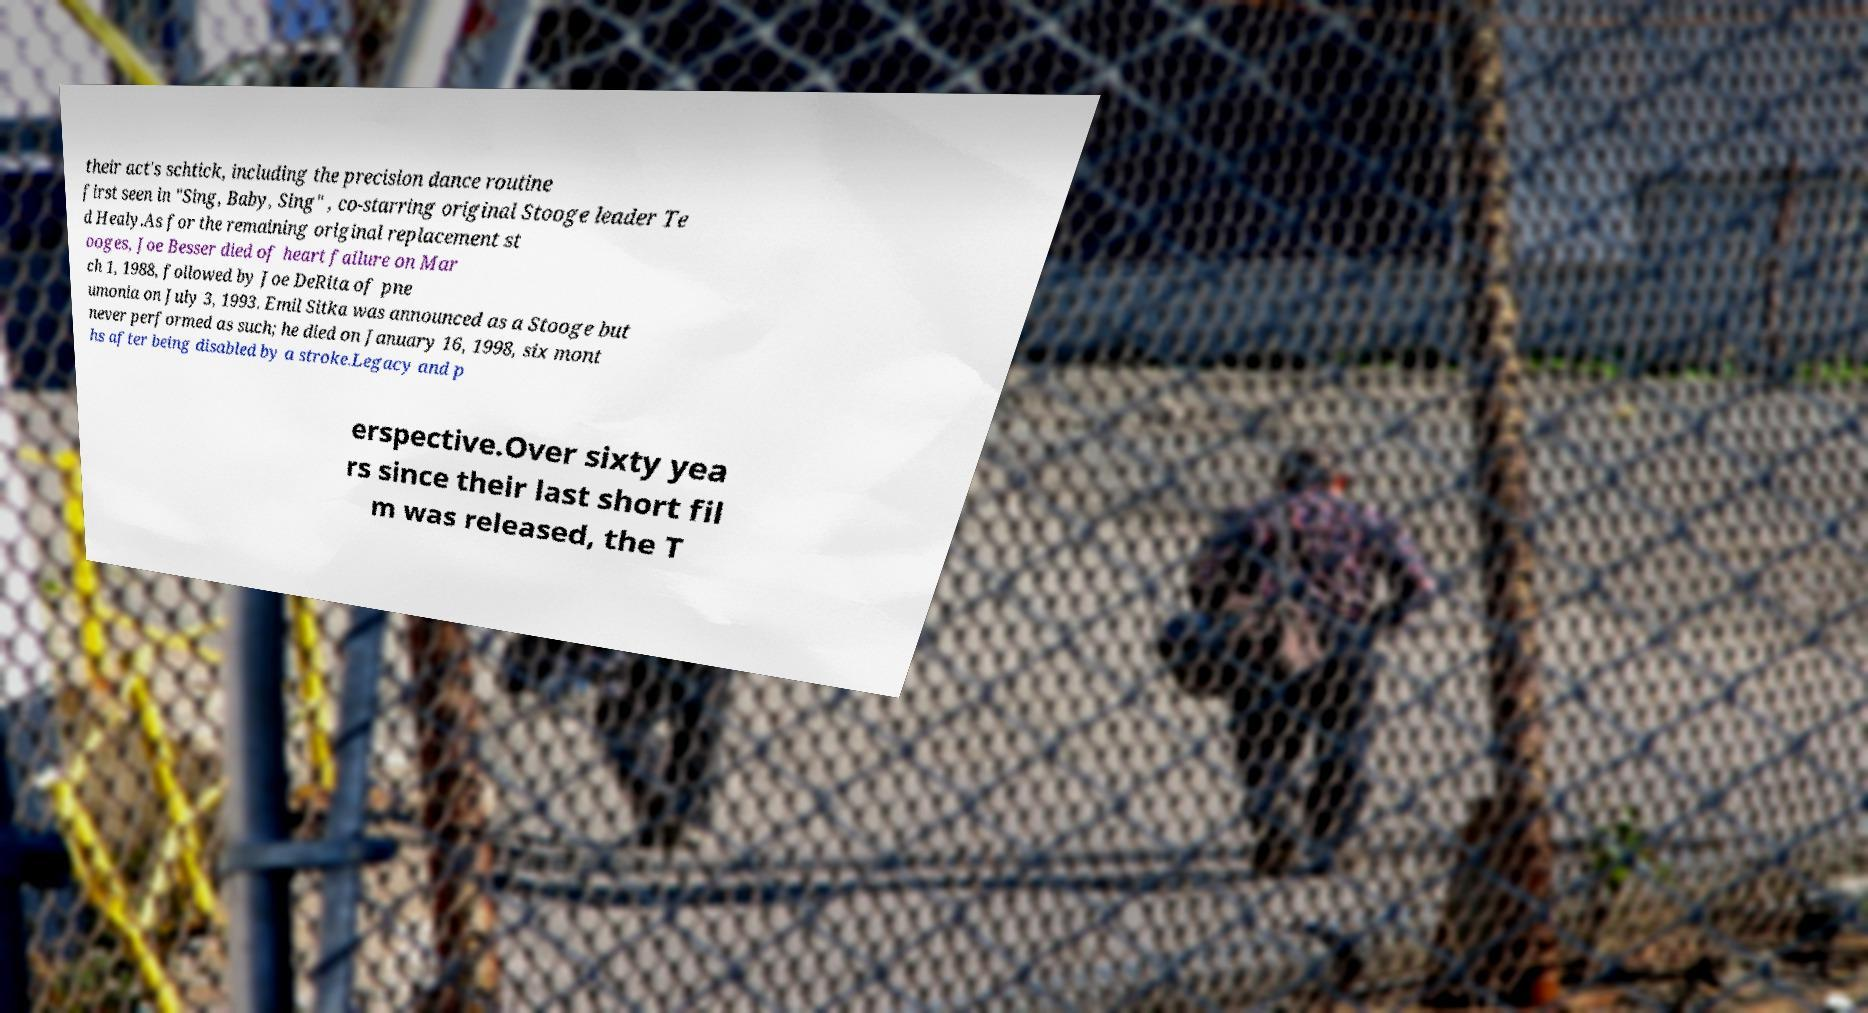Can you read and provide the text displayed in the image?This photo seems to have some interesting text. Can you extract and type it out for me? their act's schtick, including the precision dance routine first seen in "Sing, Baby, Sing" , co-starring original Stooge leader Te d Healy.As for the remaining original replacement st ooges, Joe Besser died of heart failure on Mar ch 1, 1988, followed by Joe DeRita of pne umonia on July 3, 1993. Emil Sitka was announced as a Stooge but never performed as such; he died on January 16, 1998, six mont hs after being disabled by a stroke.Legacy and p erspective.Over sixty yea rs since their last short fil m was released, the T 